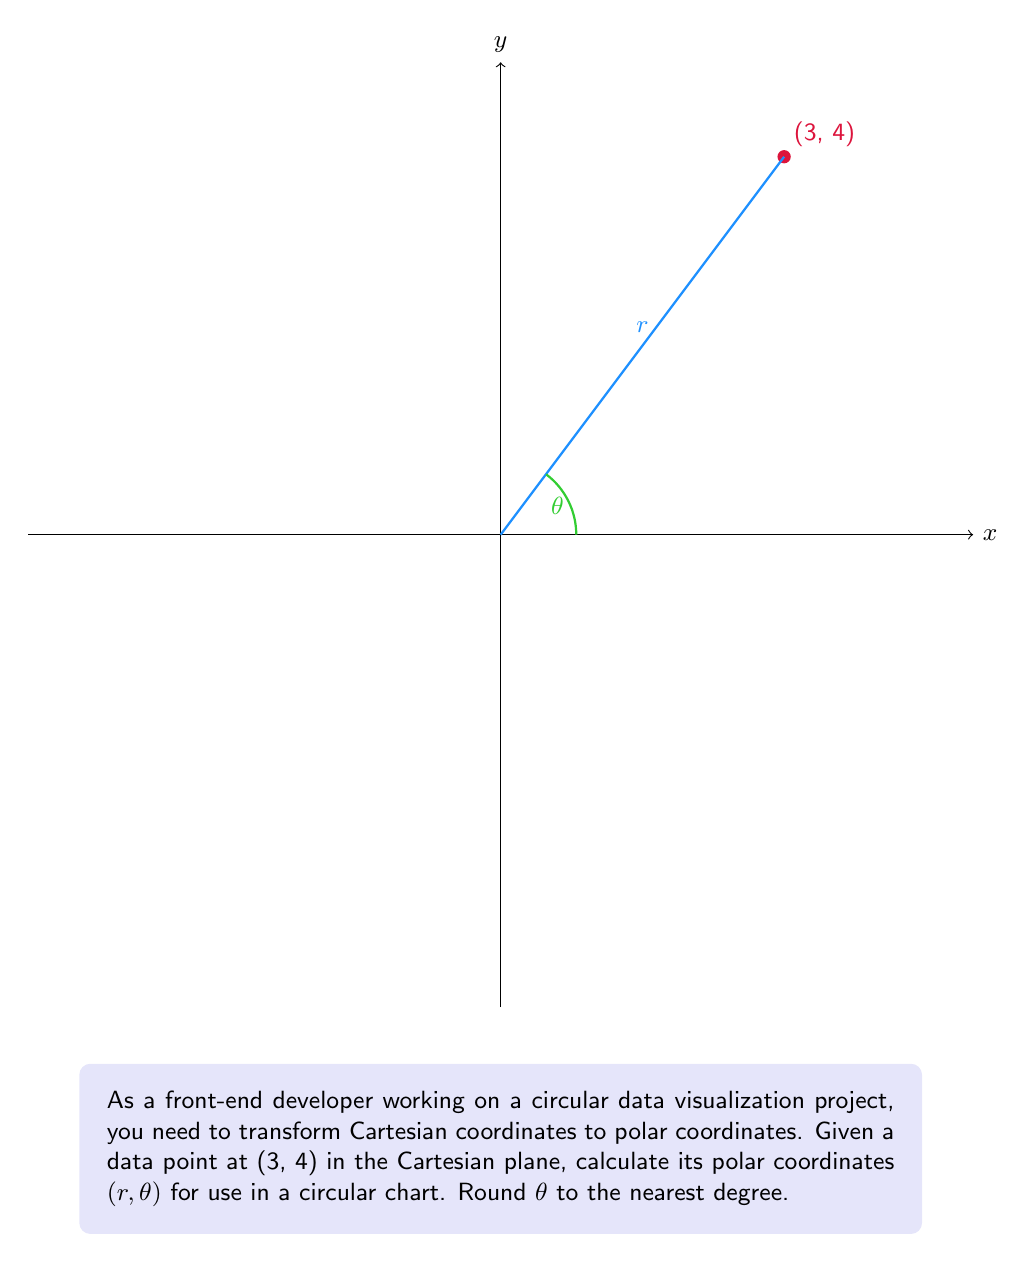Can you answer this question? To transform Cartesian coordinates (x, y) to polar coordinates (r, θ), we use the following formulas:

1. For the radius r:
   $$r = \sqrt{x^2 + y^2}$$

2. For the angle θ (in radians):
   $$\theta = \tan^{-1}\left(\frac{y}{x}\right)$$

Given the point (3, 4):

1. Calculate r:
   $$r = \sqrt{3^2 + 4^2} = \sqrt{9 + 16} = \sqrt{25} = 5$$

2. Calculate θ in radians:
   $$\theta = \tan^{-1}\left(\frac{4}{3}\right) \approx 0.9272952180$$

3. Convert θ to degrees:
   $$\theta_{degrees} = \theta_{radians} \times \frac{180°}{\pi} \approx 53.13010235°$$

4. Round θ to the nearest degree:
   $$\theta_{rounded} = 53°$$

Therefore, the polar coordinates are (5, 53°).
Answer: (5, 53°) 